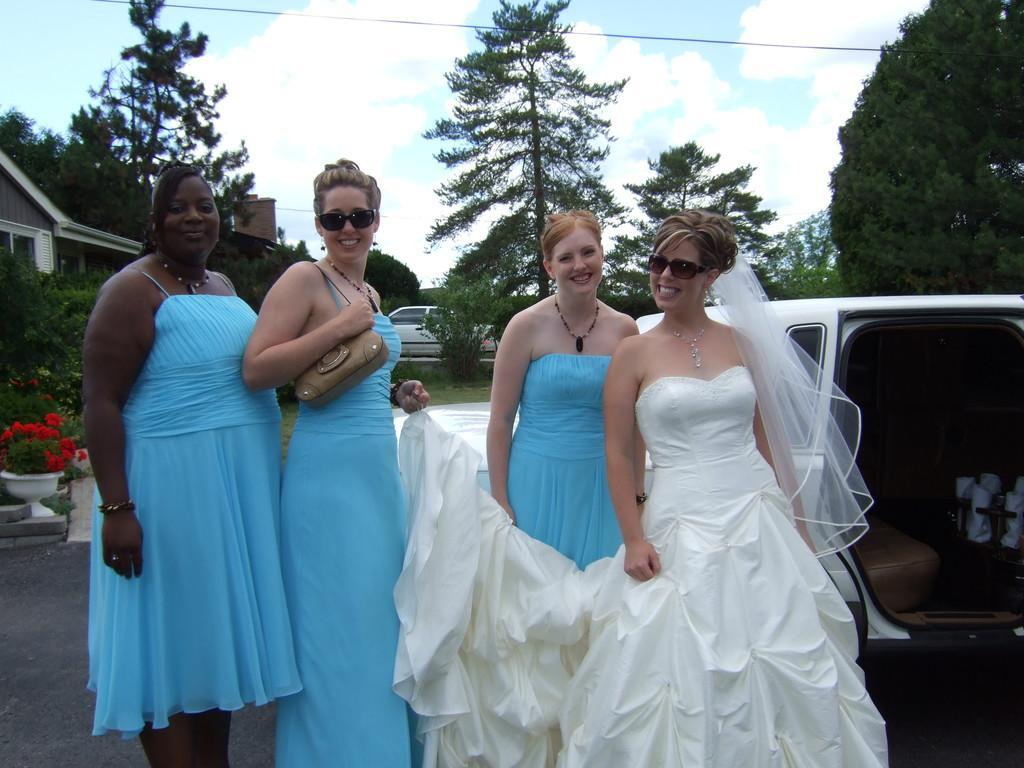Please provide a concise description of this image. In front of the picture, we see four women are standing. Three of them are wearing the blue dresses and the woman on the right side is wearing the white dress. All of them are smiling and they are posing for the photo. Behind them, we see a white car. On the left side, we see the trees, flower pot and the plants which have the red flowers. There are trees, buildings and a white car in the background. At the top, we see the sky and the clouds. 